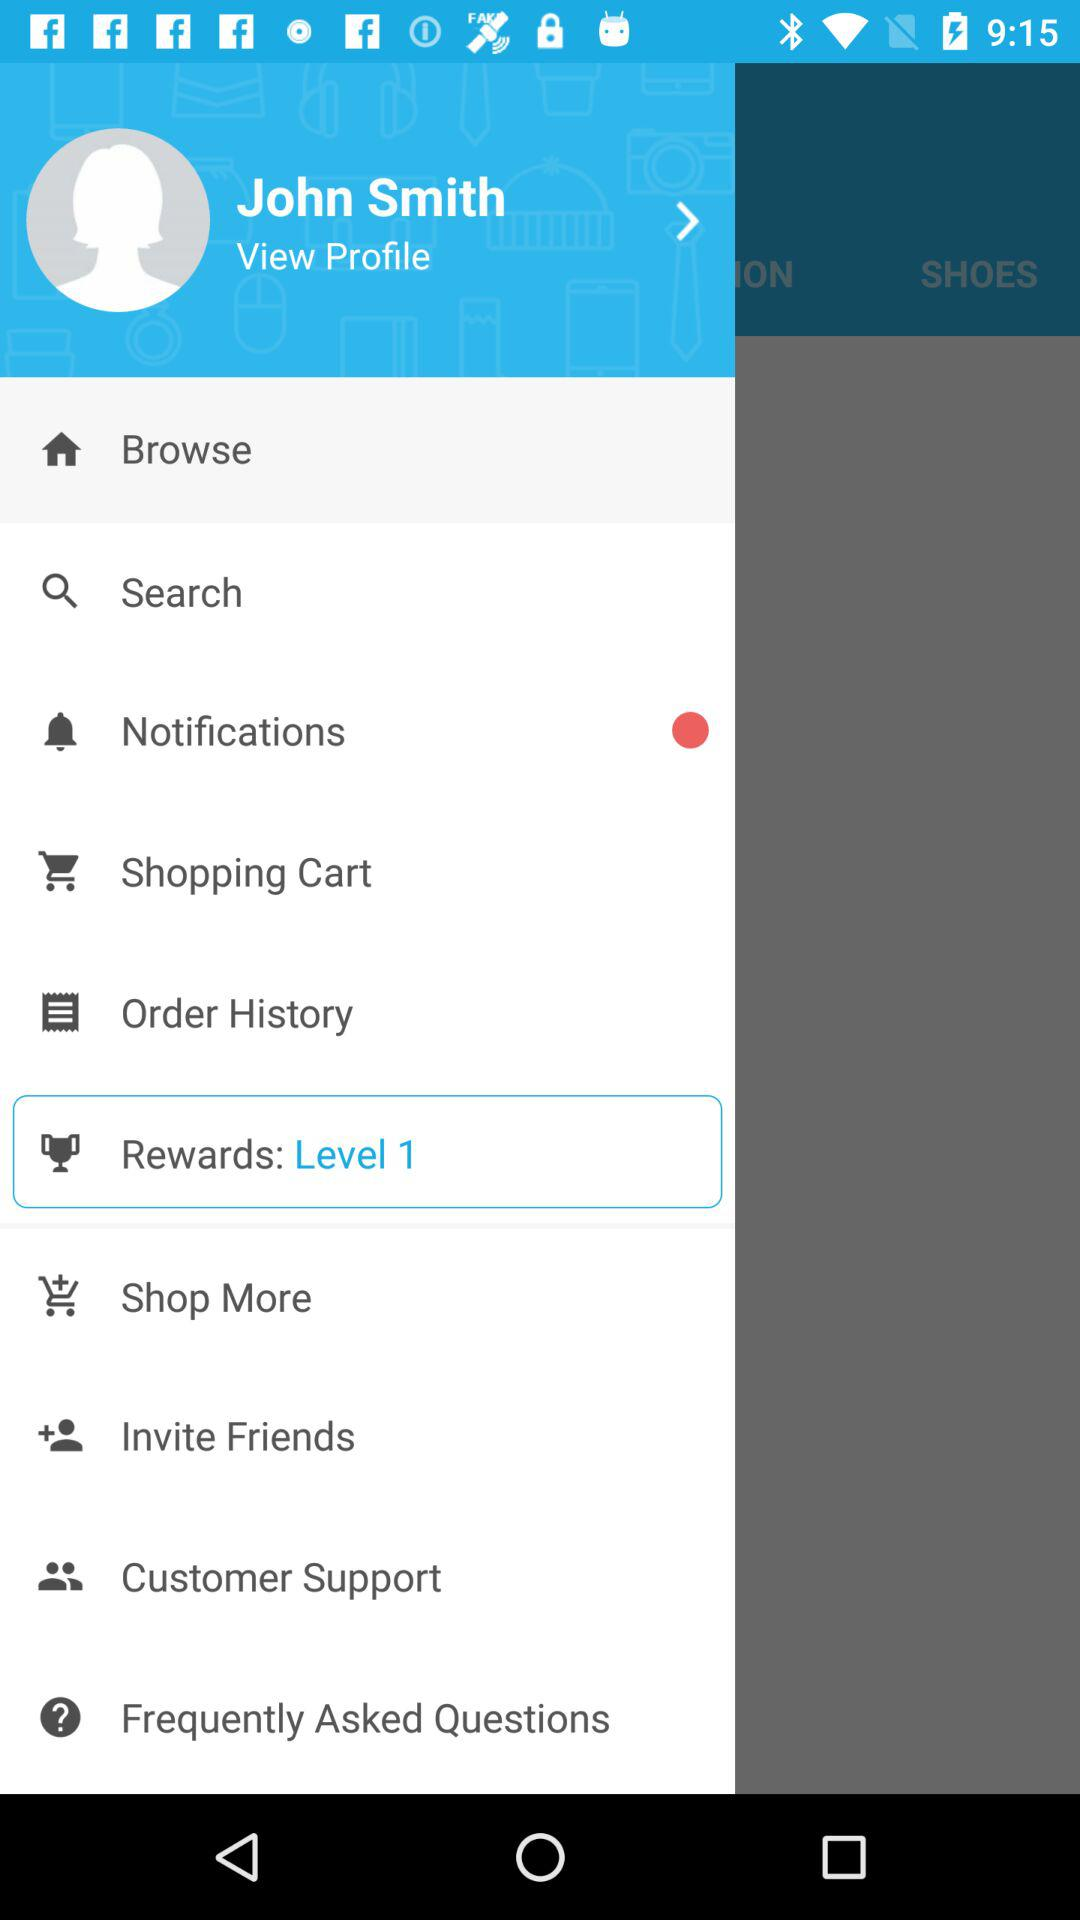How many items have a red circle next to them?
Answer the question using a single word or phrase. 1 